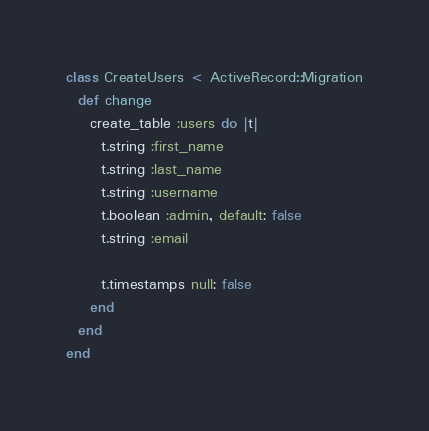Convert code to text. <code><loc_0><loc_0><loc_500><loc_500><_Ruby_>class CreateUsers < ActiveRecord::Migration
  def change
    create_table :users do |t|
      t.string :first_name
      t.string :last_name
      t.string :username
      t.boolean :admin, default: false
      t.string :email

      t.timestamps null: false
    end
  end
end
</code> 